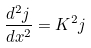<formula> <loc_0><loc_0><loc_500><loc_500>\frac { d ^ { 2 } j } { d x ^ { 2 } } = K ^ { 2 } j</formula> 